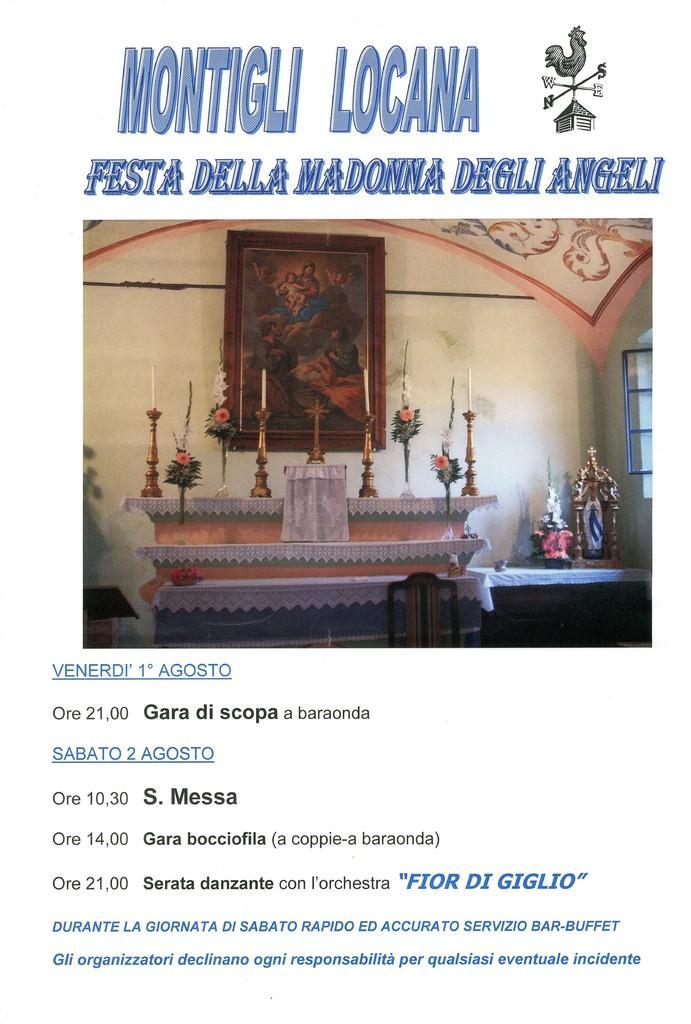Please provide a concise description of this image. In the middle of the picture, we see a table on which the candle stands are placed. Beside that, we see a table on which a candle stand and an object are placed. In the background, we see a wall on which a photo frame is placed. At the top and at the bottom, we see some text written. In the background, it is white in color. This picture might be a poster. 